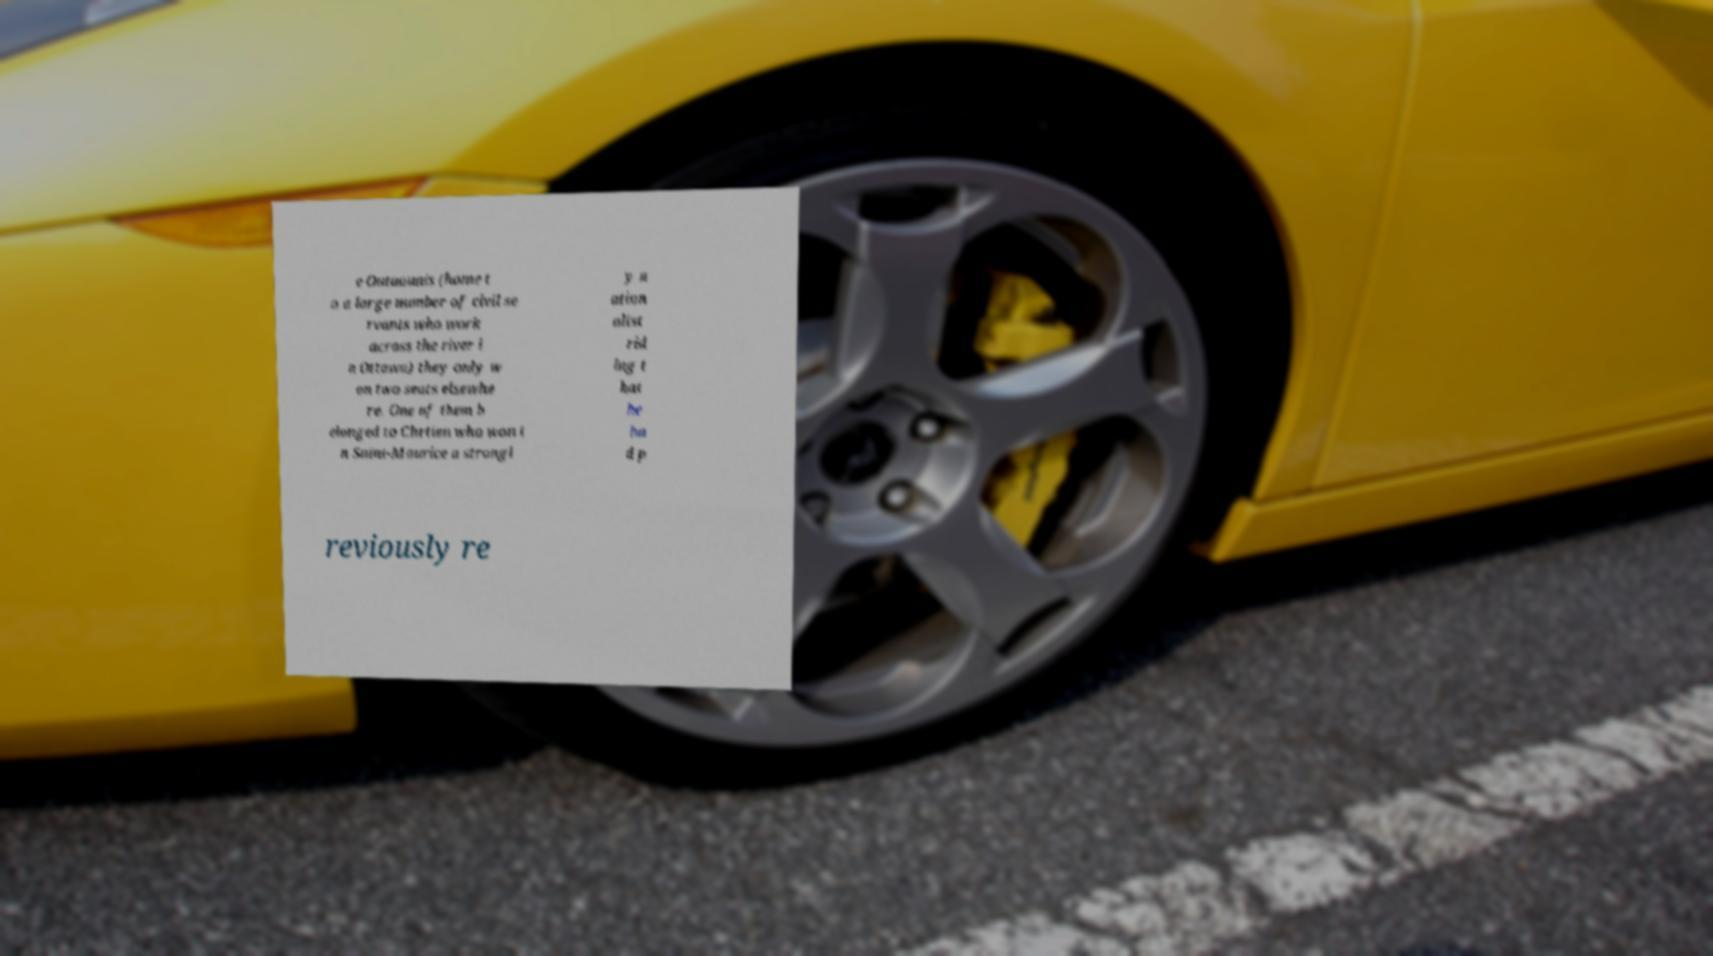Can you accurately transcribe the text from the provided image for me? e Outaouais (home t o a large number of civil se rvants who work across the river i n Ottawa) they only w on two seats elsewhe re. One of them b elonged to Chrtien who won i n Saint-Maurice a strongl y n ation alist rid ing t hat he ha d p reviously re 